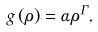Convert formula to latex. <formula><loc_0><loc_0><loc_500><loc_500>g \left ( \rho \right ) = \alpha \rho ^ { \Gamma } ,</formula> 